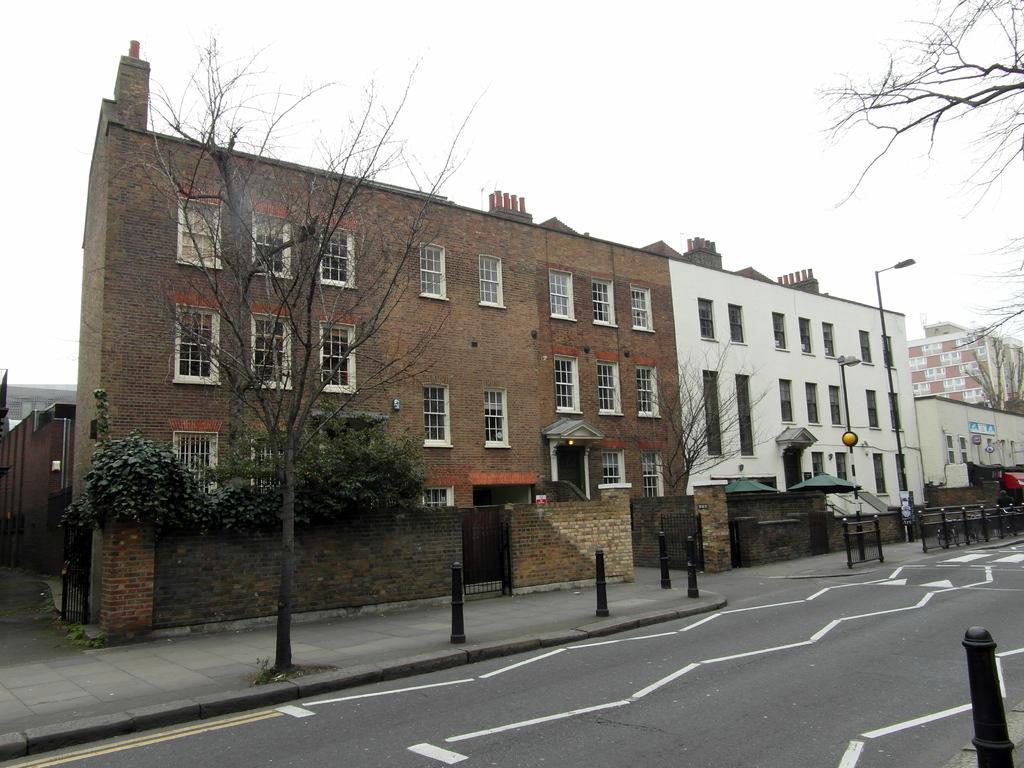Please provide a concise description of this image. This is the picture of a building. In this image there are buildings and there are trees and poles on the footpath. On the right side of the image there is a railing on the footpath. At the top there is sky. At the bottom there is a road and there are white lines on the road. 